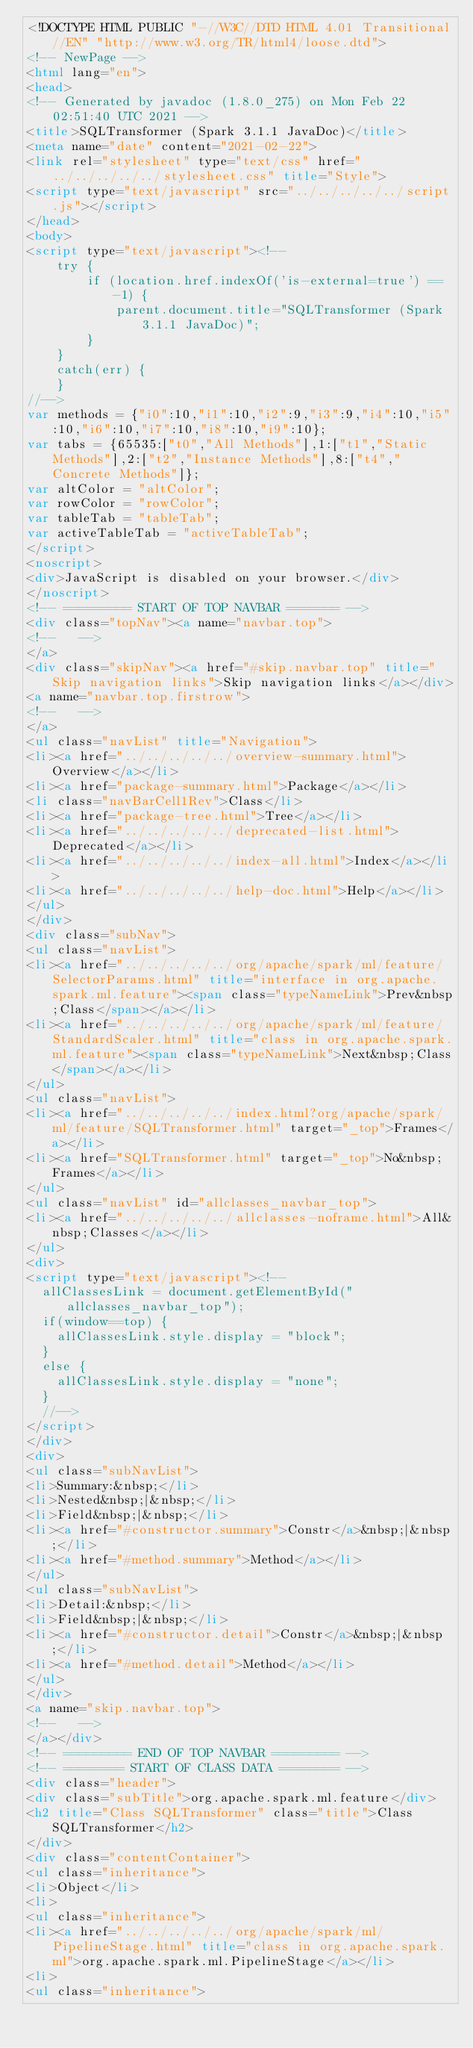<code> <loc_0><loc_0><loc_500><loc_500><_HTML_><!DOCTYPE HTML PUBLIC "-//W3C//DTD HTML 4.01 Transitional//EN" "http://www.w3.org/TR/html4/loose.dtd">
<!-- NewPage -->
<html lang="en">
<head>
<!-- Generated by javadoc (1.8.0_275) on Mon Feb 22 02:51:40 UTC 2021 -->
<title>SQLTransformer (Spark 3.1.1 JavaDoc)</title>
<meta name="date" content="2021-02-22">
<link rel="stylesheet" type="text/css" href="../../../../../stylesheet.css" title="Style">
<script type="text/javascript" src="../../../../../script.js"></script>
</head>
<body>
<script type="text/javascript"><!--
    try {
        if (location.href.indexOf('is-external=true') == -1) {
            parent.document.title="SQLTransformer (Spark 3.1.1 JavaDoc)";
        }
    }
    catch(err) {
    }
//-->
var methods = {"i0":10,"i1":10,"i2":9,"i3":9,"i4":10,"i5":10,"i6":10,"i7":10,"i8":10,"i9":10};
var tabs = {65535:["t0","All Methods"],1:["t1","Static Methods"],2:["t2","Instance Methods"],8:["t4","Concrete Methods"]};
var altColor = "altColor";
var rowColor = "rowColor";
var tableTab = "tableTab";
var activeTableTab = "activeTableTab";
</script>
<noscript>
<div>JavaScript is disabled on your browser.</div>
</noscript>
<!-- ========= START OF TOP NAVBAR ======= -->
<div class="topNav"><a name="navbar.top">
<!--   -->
</a>
<div class="skipNav"><a href="#skip.navbar.top" title="Skip navigation links">Skip navigation links</a></div>
<a name="navbar.top.firstrow">
<!--   -->
</a>
<ul class="navList" title="Navigation">
<li><a href="../../../../../overview-summary.html">Overview</a></li>
<li><a href="package-summary.html">Package</a></li>
<li class="navBarCell1Rev">Class</li>
<li><a href="package-tree.html">Tree</a></li>
<li><a href="../../../../../deprecated-list.html">Deprecated</a></li>
<li><a href="../../../../../index-all.html">Index</a></li>
<li><a href="../../../../../help-doc.html">Help</a></li>
</ul>
</div>
<div class="subNav">
<ul class="navList">
<li><a href="../../../../../org/apache/spark/ml/feature/SelectorParams.html" title="interface in org.apache.spark.ml.feature"><span class="typeNameLink">Prev&nbsp;Class</span></a></li>
<li><a href="../../../../../org/apache/spark/ml/feature/StandardScaler.html" title="class in org.apache.spark.ml.feature"><span class="typeNameLink">Next&nbsp;Class</span></a></li>
</ul>
<ul class="navList">
<li><a href="../../../../../index.html?org/apache/spark/ml/feature/SQLTransformer.html" target="_top">Frames</a></li>
<li><a href="SQLTransformer.html" target="_top">No&nbsp;Frames</a></li>
</ul>
<ul class="navList" id="allclasses_navbar_top">
<li><a href="../../../../../allclasses-noframe.html">All&nbsp;Classes</a></li>
</ul>
<div>
<script type="text/javascript"><!--
  allClassesLink = document.getElementById("allclasses_navbar_top");
  if(window==top) {
    allClassesLink.style.display = "block";
  }
  else {
    allClassesLink.style.display = "none";
  }
  //-->
</script>
</div>
<div>
<ul class="subNavList">
<li>Summary:&nbsp;</li>
<li>Nested&nbsp;|&nbsp;</li>
<li>Field&nbsp;|&nbsp;</li>
<li><a href="#constructor.summary">Constr</a>&nbsp;|&nbsp;</li>
<li><a href="#method.summary">Method</a></li>
</ul>
<ul class="subNavList">
<li>Detail:&nbsp;</li>
<li>Field&nbsp;|&nbsp;</li>
<li><a href="#constructor.detail">Constr</a>&nbsp;|&nbsp;</li>
<li><a href="#method.detail">Method</a></li>
</ul>
</div>
<a name="skip.navbar.top">
<!--   -->
</a></div>
<!-- ========= END OF TOP NAVBAR ========= -->
<!-- ======== START OF CLASS DATA ======== -->
<div class="header">
<div class="subTitle">org.apache.spark.ml.feature</div>
<h2 title="Class SQLTransformer" class="title">Class SQLTransformer</h2>
</div>
<div class="contentContainer">
<ul class="inheritance">
<li>Object</li>
<li>
<ul class="inheritance">
<li><a href="../../../../../org/apache/spark/ml/PipelineStage.html" title="class in org.apache.spark.ml">org.apache.spark.ml.PipelineStage</a></li>
<li>
<ul class="inheritance"></code> 